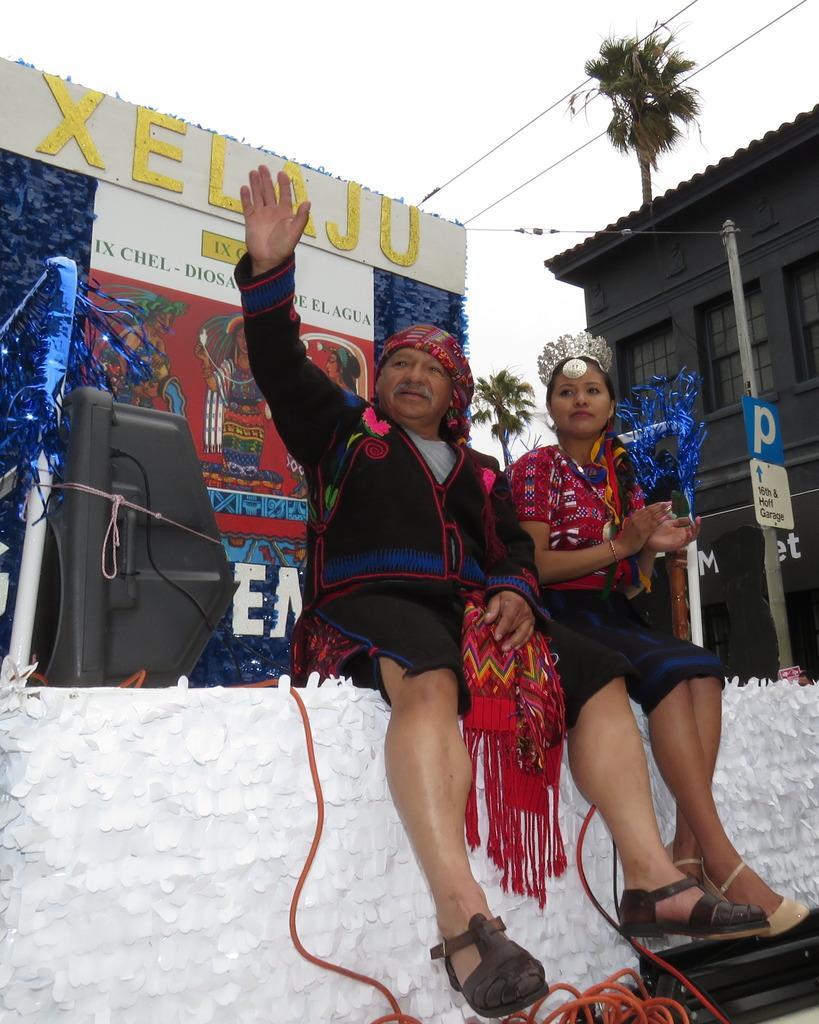In one or two sentences, can you explain what this image depicts? In this image there are persons sitting on wall holding and objects which are red and blue in colour. On the right side there is a pole and there is a building and there are trees. In the background there is a banner with some text written on it and on the left side in the front there is an object which is black in colour and the sky is cloudy. 